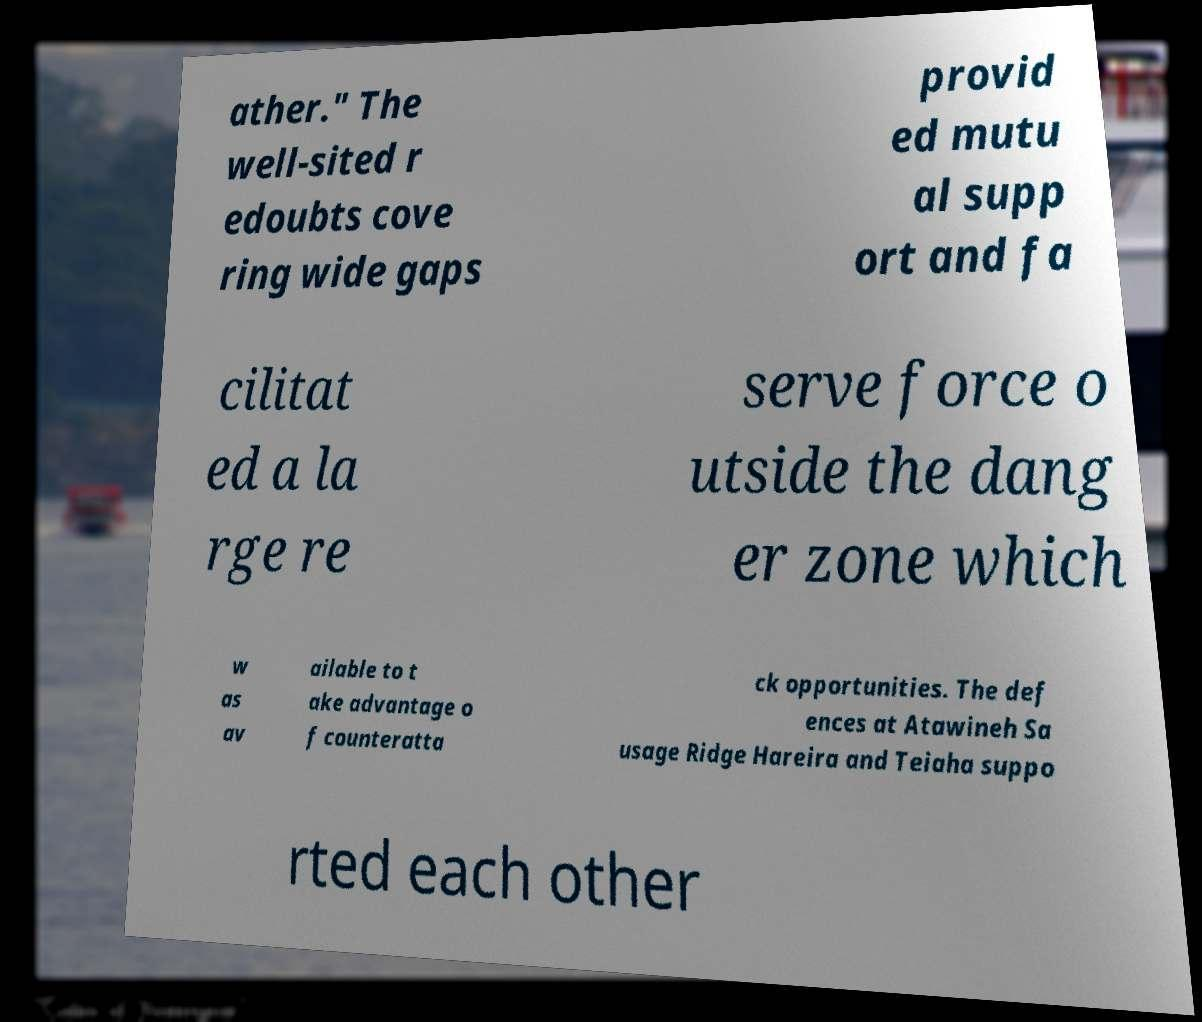I need the written content from this picture converted into text. Can you do that? ather." The well-sited r edoubts cove ring wide gaps provid ed mutu al supp ort and fa cilitat ed a la rge re serve force o utside the dang er zone which w as av ailable to t ake advantage o f counteratta ck opportunities. The def ences at Atawineh Sa usage Ridge Hareira and Teiaha suppo rted each other 